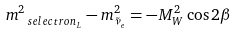Convert formula to latex. <formula><loc_0><loc_0><loc_500><loc_500>m ^ { 2 } _ { \ s e l e c t r o n _ { L } } - m ^ { 2 } _ { \tilde { \nu } _ { e } } = - M ^ { 2 } _ { W } \cos 2 \beta</formula> 